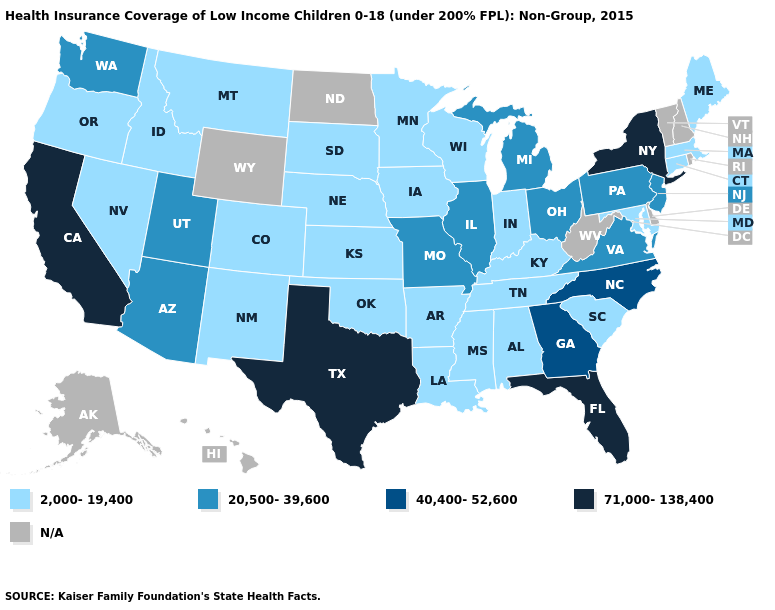Name the states that have a value in the range 20,500-39,600?
Give a very brief answer. Arizona, Illinois, Michigan, Missouri, New Jersey, Ohio, Pennsylvania, Utah, Virginia, Washington. What is the value of Washington?
Quick response, please. 20,500-39,600. What is the highest value in the West ?
Write a very short answer. 71,000-138,400. Name the states that have a value in the range 71,000-138,400?
Answer briefly. California, Florida, New York, Texas. What is the value of Colorado?
Write a very short answer. 2,000-19,400. Name the states that have a value in the range N/A?
Be succinct. Alaska, Delaware, Hawaii, New Hampshire, North Dakota, Rhode Island, Vermont, West Virginia, Wyoming. Which states have the lowest value in the USA?
Concise answer only. Alabama, Arkansas, Colorado, Connecticut, Idaho, Indiana, Iowa, Kansas, Kentucky, Louisiana, Maine, Maryland, Massachusetts, Minnesota, Mississippi, Montana, Nebraska, Nevada, New Mexico, Oklahoma, Oregon, South Carolina, South Dakota, Tennessee, Wisconsin. What is the highest value in the South ?
Concise answer only. 71,000-138,400. Which states hav the highest value in the MidWest?
Be succinct. Illinois, Michigan, Missouri, Ohio. Name the states that have a value in the range N/A?
Give a very brief answer. Alaska, Delaware, Hawaii, New Hampshire, North Dakota, Rhode Island, Vermont, West Virginia, Wyoming. What is the value of New Jersey?
Be succinct. 20,500-39,600. What is the lowest value in the West?
Keep it brief. 2,000-19,400. Does the first symbol in the legend represent the smallest category?
Write a very short answer. Yes. Which states have the lowest value in the USA?
Write a very short answer. Alabama, Arkansas, Colorado, Connecticut, Idaho, Indiana, Iowa, Kansas, Kentucky, Louisiana, Maine, Maryland, Massachusetts, Minnesota, Mississippi, Montana, Nebraska, Nevada, New Mexico, Oklahoma, Oregon, South Carolina, South Dakota, Tennessee, Wisconsin. 